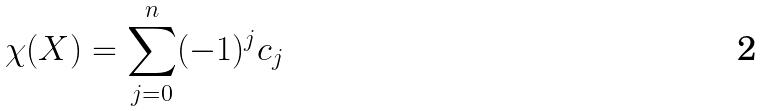Convert formula to latex. <formula><loc_0><loc_0><loc_500><loc_500>\chi ( X ) = \sum _ { j = 0 } ^ { n } ( - 1 ) ^ { j } c _ { j }</formula> 